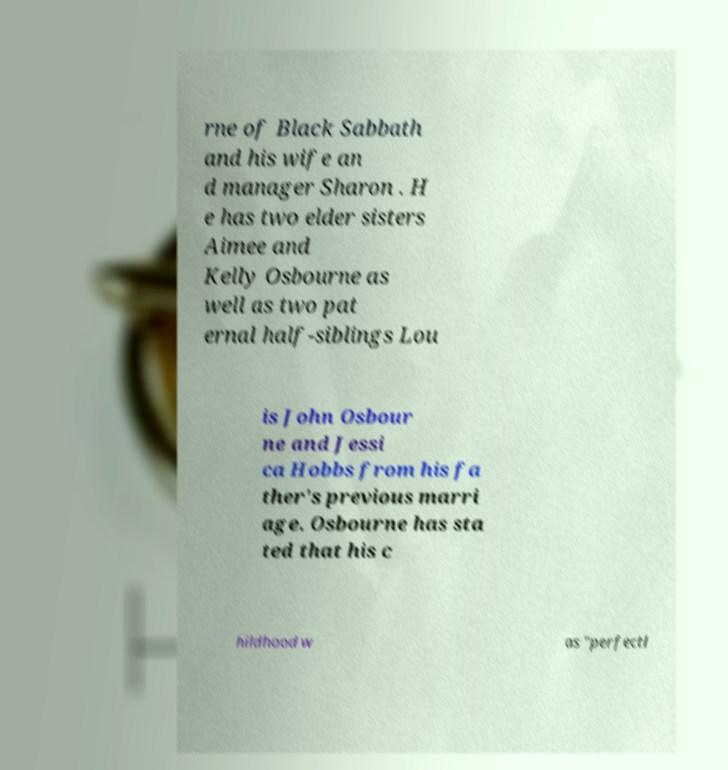Can you accurately transcribe the text from the provided image for me? rne of Black Sabbath and his wife an d manager Sharon . H e has two elder sisters Aimee and Kelly Osbourne as well as two pat ernal half-siblings Lou is John Osbour ne and Jessi ca Hobbs from his fa ther's previous marri age. Osbourne has sta ted that his c hildhood w as "perfectl 